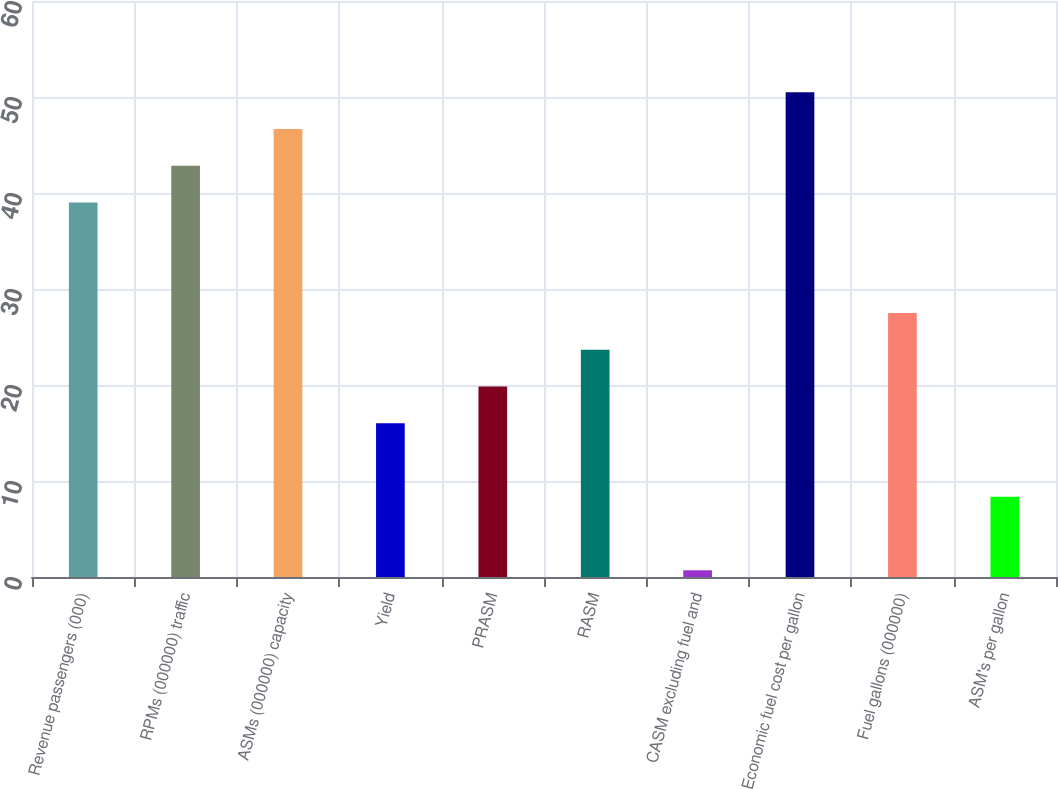<chart> <loc_0><loc_0><loc_500><loc_500><bar_chart><fcel>Revenue passengers (000)<fcel>RPMs (000000) traffic<fcel>ASMs (000000) capacity<fcel>Yield<fcel>PRASM<fcel>RASM<fcel>CASM excluding fuel and<fcel>Economic fuel cost per gallon<fcel>Fuel gallons (000000)<fcel>ASM's per gallon<nl><fcel>39<fcel>42.83<fcel>46.66<fcel>16.02<fcel>19.85<fcel>23.68<fcel>0.7<fcel>50.49<fcel>27.51<fcel>8.36<nl></chart> 